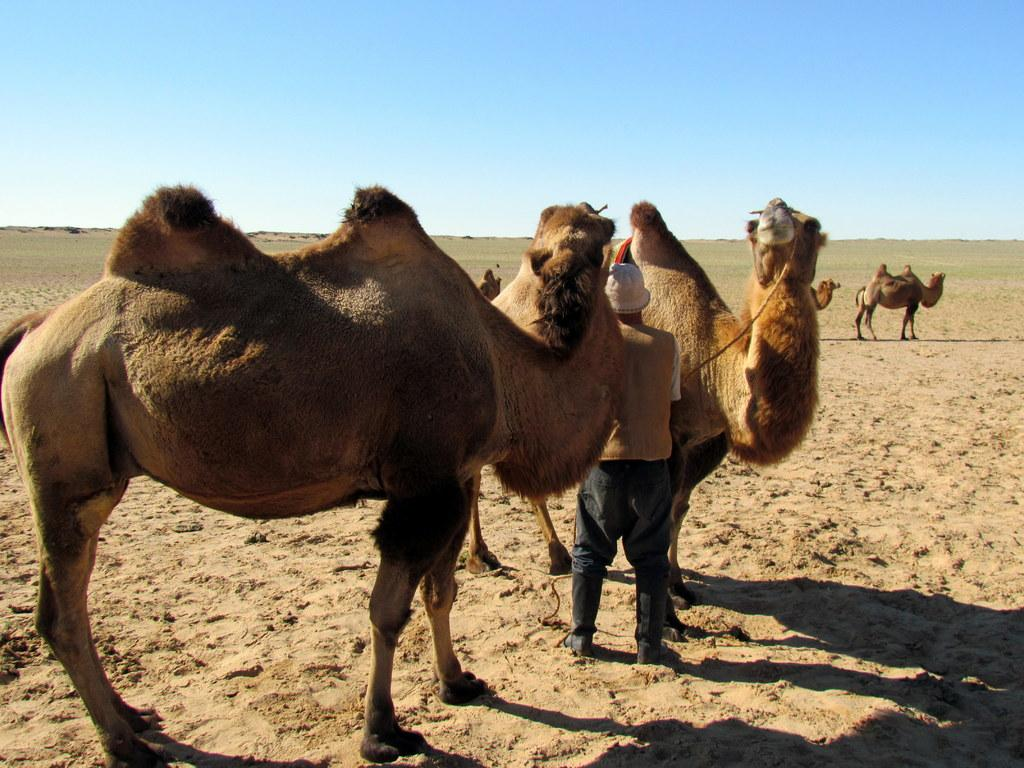What animals are present in the image? There are camels in the image. What type of environment is depicted in the image? The camels are in a desert setting. Are there any people in the image? Yes, there are people standing beside the camels. What can be inferred about the weather in the image? The climate appears to be sunny. What type of jellyfish can be seen swimming in the desert in the image? There are no jellyfish present in the image, as it depicts a desert setting with camels and people. 